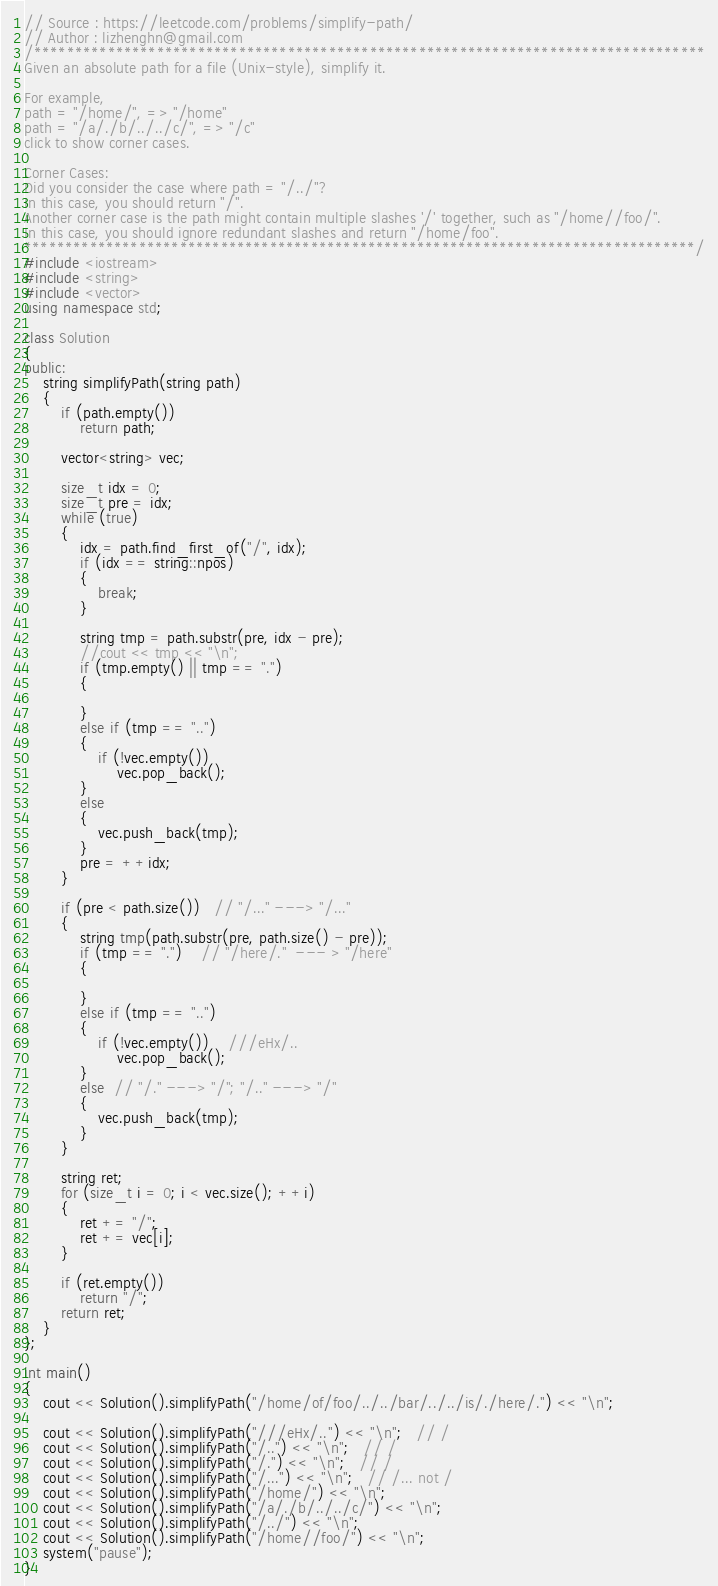Convert code to text. <code><loc_0><loc_0><loc_500><loc_500><_C++_>// Source : https://leetcode.com/problems/simplify-path/
// Author : lizhenghn@gmail.com
/**********************************************************************************
Given an absolute path for a file (Unix-style), simplify it.

For example,
path = "/home/", => "/home"
path = "/a/./b/../../c/", => "/c"
click to show corner cases.

Corner Cases:
Did you consider the case where path = "/../"?
In this case, you should return "/".
Another corner case is the path might contain multiple slashes '/' together, such as "/home//foo/".
In this case, you should ignore redundant slashes and return "/home/foo".
**********************************************************************************/
#include <iostream>
#include <string>
#include <vector>
using namespace std;

class Solution
{
public:
	string simplifyPath(string path)
	{
		if (path.empty())
			return path;

		vector<string> vec;

		size_t idx = 0;
		size_t pre = idx;
		while (true)
		{
			idx = path.find_first_of("/", idx);
			if (idx == string::npos)
			{
				break;
			}

			string tmp = path.substr(pre, idx - pre);
			//cout << tmp << "\n";
			if (tmp.empty() || tmp == ".")
			{

			}
			else if (tmp == "..")
			{
				if (!vec.empty())
					vec.pop_back();
			}
			else
			{
				vec.push_back(tmp);
			}
			pre = ++idx;
		}

		if (pre < path.size())   // "/..." ---> "/..."
		{
			string tmp(path.substr(pre, path.size() - pre));
			if (tmp == ".")    // "/here/."  --- > "/here"
			{

			}
			else if (tmp == "..")     
			{
				if (!vec.empty())    ///eHx/..
					vec.pop_back();
			}
			else  // "/." ---> "/"; "/.." ---> "/"
			{
				vec.push_back(tmp);
			}
		}

		string ret;
		for (size_t i = 0; i < vec.size(); ++i)
		{
			ret += "/";
			ret += vec[i];
		}

		if (ret.empty())
			return "/";
		return ret;
	}
};

int main()
{
	cout << Solution().simplifyPath("/home/of/foo/../../bar/../../is/./here/.") << "\n";
	
	cout << Solution().simplifyPath("///eHx/..") << "\n";   // /
	cout << Solution().simplifyPath("/..") << "\n";   // /
	cout << Solution().simplifyPath("/.") << "\n";   // /
	cout << Solution().simplifyPath("/...") << "\n";   // /... not /
	cout << Solution().simplifyPath("/home/") << "\n";
	cout << Solution().simplifyPath("/a/./b/../../c/") << "\n";
	cout << Solution().simplifyPath("/../") << "\n";
	cout << Solution().simplifyPath("/home//foo/") << "\n";
	system("pause");
}</code> 